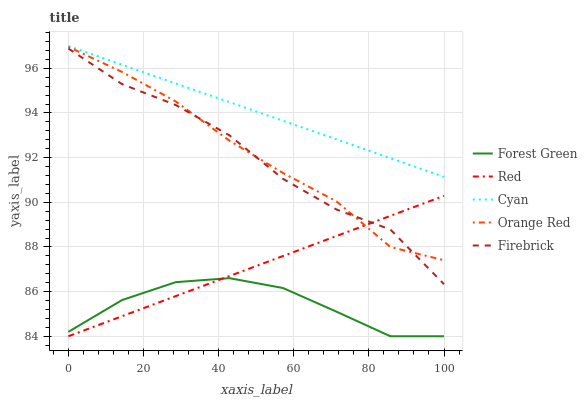Does Forest Green have the minimum area under the curve?
Answer yes or no. Yes. Does Cyan have the maximum area under the curve?
Answer yes or no. Yes. Does Firebrick have the minimum area under the curve?
Answer yes or no. No. Does Firebrick have the maximum area under the curve?
Answer yes or no. No. Is Red the smoothest?
Answer yes or no. Yes. Is Firebrick the roughest?
Answer yes or no. Yes. Is Forest Green the smoothest?
Answer yes or no. No. Is Forest Green the roughest?
Answer yes or no. No. Does Forest Green have the lowest value?
Answer yes or no. Yes. Does Firebrick have the lowest value?
Answer yes or no. No. Does Cyan have the highest value?
Answer yes or no. Yes. Does Firebrick have the highest value?
Answer yes or no. No. Is Red less than Cyan?
Answer yes or no. Yes. Is Cyan greater than Red?
Answer yes or no. Yes. Does Forest Green intersect Red?
Answer yes or no. Yes. Is Forest Green less than Red?
Answer yes or no. No. Is Forest Green greater than Red?
Answer yes or no. No. Does Red intersect Cyan?
Answer yes or no. No. 